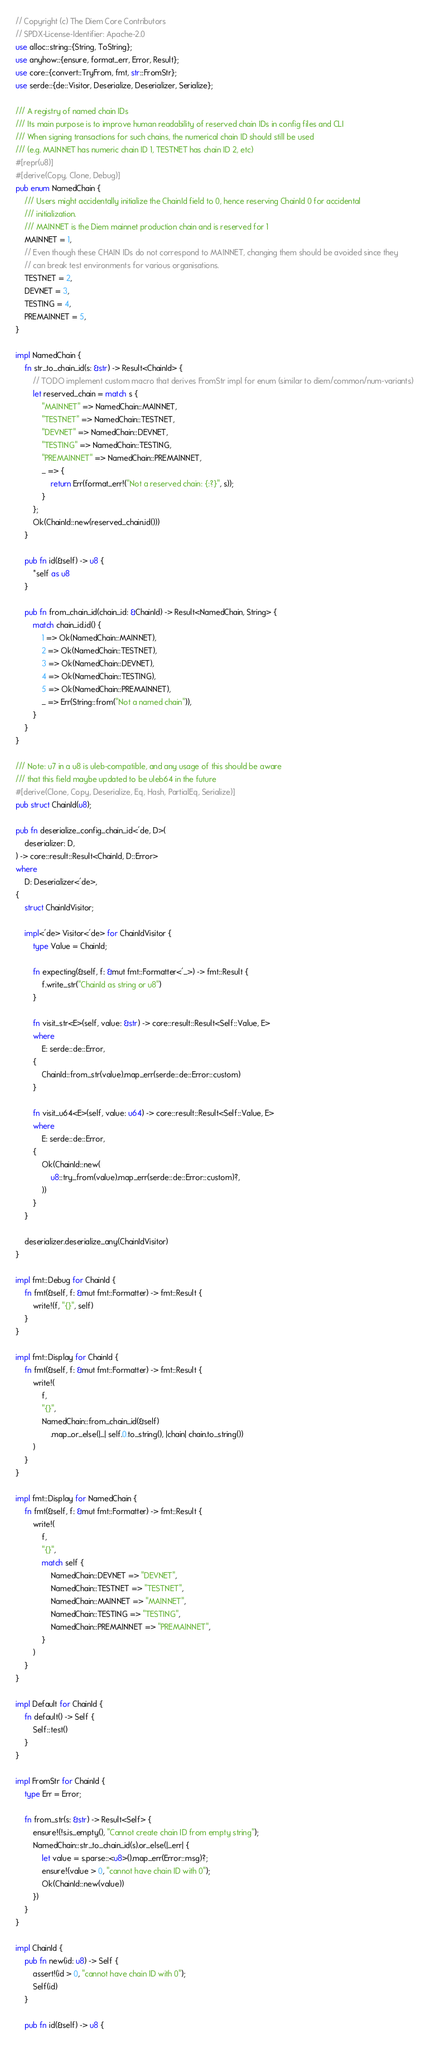<code> <loc_0><loc_0><loc_500><loc_500><_Rust_>// Copyright (c) The Diem Core Contributors
// SPDX-License-Identifier: Apache-2.0
use alloc::string::{String, ToString};
use anyhow::{ensure, format_err, Error, Result};
use core::{convert::TryFrom, fmt, str::FromStr};
use serde::{de::Visitor, Deserialize, Deserializer, Serialize};

/// A registry of named chain IDs
/// Its main purpose is to improve human readability of reserved chain IDs in config files and CLI
/// When signing transactions for such chains, the numerical chain ID should still be used
/// (e.g. MAINNET has numeric chain ID 1, TESTNET has chain ID 2, etc)
#[repr(u8)]
#[derive(Copy, Clone, Debug)]
pub enum NamedChain {
    /// Users might accidentally initialize the ChainId field to 0, hence reserving ChainId 0 for accidental
    /// initialization.
    /// MAINNET is the Diem mainnet production chain and is reserved for 1
    MAINNET = 1,
    // Even though these CHAIN IDs do not correspond to MAINNET, changing them should be avoided since they
    // can break test environments for various organisations.
    TESTNET = 2,
    DEVNET = 3,
    TESTING = 4,
    PREMAINNET = 5,
}

impl NamedChain {
    fn str_to_chain_id(s: &str) -> Result<ChainId> {
        // TODO implement custom macro that derives FromStr impl for enum (similar to diem/common/num-variants)
        let reserved_chain = match s {
            "MAINNET" => NamedChain::MAINNET,
            "TESTNET" => NamedChain::TESTNET,
            "DEVNET" => NamedChain::DEVNET,
            "TESTING" => NamedChain::TESTING,
            "PREMAINNET" => NamedChain::PREMAINNET,
            _ => {
                return Err(format_err!("Not a reserved chain: {:?}", s));
            }
        };
        Ok(ChainId::new(reserved_chain.id()))
    }

    pub fn id(&self) -> u8 {
        *self as u8
    }

    pub fn from_chain_id(chain_id: &ChainId) -> Result<NamedChain, String> {
        match chain_id.id() {
            1 => Ok(NamedChain::MAINNET),
            2 => Ok(NamedChain::TESTNET),
            3 => Ok(NamedChain::DEVNET),
            4 => Ok(NamedChain::TESTING),
            5 => Ok(NamedChain::PREMAINNET),
            _ => Err(String::from("Not a named chain")),
        }
    }
}

/// Note: u7 in a u8 is uleb-compatible, and any usage of this should be aware
/// that this field maybe updated to be uleb64 in the future
#[derive(Clone, Copy, Deserialize, Eq, Hash, PartialEq, Serialize)]
pub struct ChainId(u8);

pub fn deserialize_config_chain_id<'de, D>(
    deserializer: D,
) -> core::result::Result<ChainId, D::Error>
where
    D: Deserializer<'de>,
{
    struct ChainIdVisitor;

    impl<'de> Visitor<'de> for ChainIdVisitor {
        type Value = ChainId;

        fn expecting(&self, f: &mut fmt::Formatter<'_>) -> fmt::Result {
            f.write_str("ChainId as string or u8")
        }

        fn visit_str<E>(self, value: &str) -> core::result::Result<Self::Value, E>
        where
            E: serde::de::Error,
        {
            ChainId::from_str(value).map_err(serde::de::Error::custom)
        }

        fn visit_u64<E>(self, value: u64) -> core::result::Result<Self::Value, E>
        where
            E: serde::de::Error,
        {
            Ok(ChainId::new(
                u8::try_from(value).map_err(serde::de::Error::custom)?,
            ))
        }
    }

    deserializer.deserialize_any(ChainIdVisitor)
}

impl fmt::Debug for ChainId {
    fn fmt(&self, f: &mut fmt::Formatter) -> fmt::Result {
        write!(f, "{}", self)
    }
}

impl fmt::Display for ChainId {
    fn fmt(&self, f: &mut fmt::Formatter) -> fmt::Result {
        write!(
            f,
            "{}",
            NamedChain::from_chain_id(&self)
                .map_or_else(|_| self.0.to_string(), |chain| chain.to_string())
        )
    }
}

impl fmt::Display for NamedChain {
    fn fmt(&self, f: &mut fmt::Formatter) -> fmt::Result {
        write!(
            f,
            "{}",
            match self {
                NamedChain::DEVNET => "DEVNET",
                NamedChain::TESTNET => "TESTNET",
                NamedChain::MAINNET => "MAINNET",
                NamedChain::TESTING => "TESTING",
                NamedChain::PREMAINNET => "PREMAINNET",
            }
        )
    }
}

impl Default for ChainId {
    fn default() -> Self {
        Self::test()
    }
}

impl FromStr for ChainId {
    type Err = Error;

    fn from_str(s: &str) -> Result<Self> {
        ensure!(!s.is_empty(), "Cannot create chain ID from empty string");
        NamedChain::str_to_chain_id(s).or_else(|_err| {
            let value = s.parse::<u8>().map_err(Error::msg)?;
            ensure!(value > 0, "cannot have chain ID with 0");
            Ok(ChainId::new(value))
        })
    }
}

impl ChainId {
    pub fn new(id: u8) -> Self {
        assert!(id > 0, "cannot have chain ID with 0");
        Self(id)
    }

    pub fn id(&self) -> u8 {</code> 